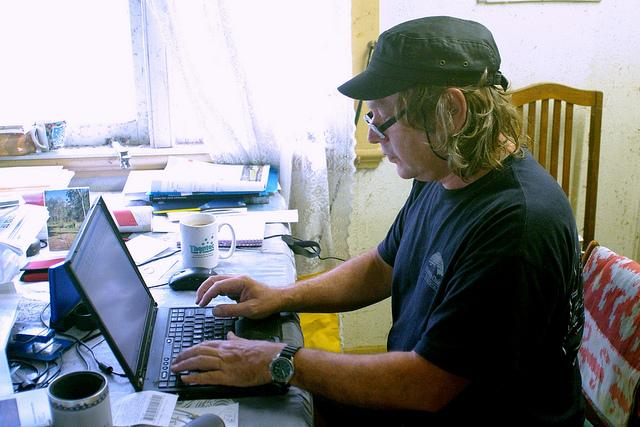Approximately what time is it? Please explain your reasoning. 255. The sky looks a bit dark. 